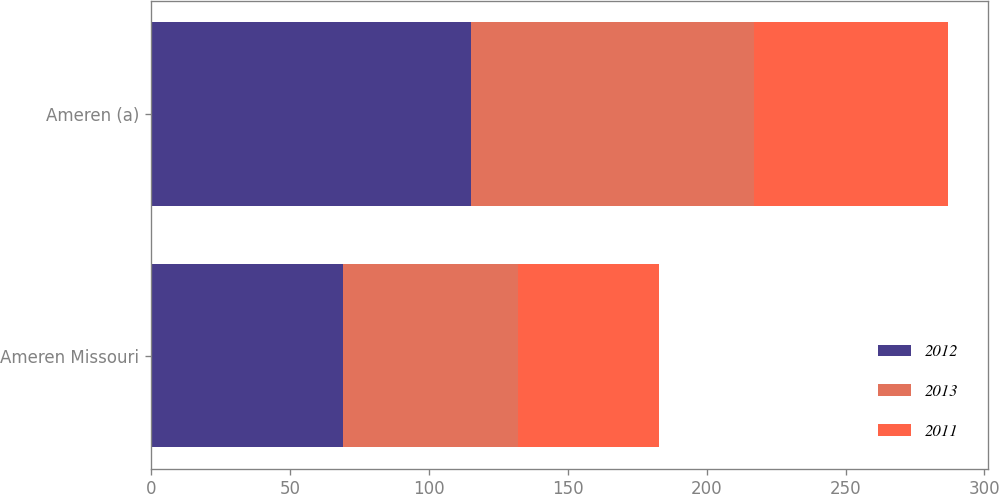Convert chart to OTSL. <chart><loc_0><loc_0><loc_500><loc_500><stacked_bar_chart><ecel><fcel>Ameren Missouri<fcel>Ameren (a)<nl><fcel>2012<fcel>69<fcel>115<nl><fcel>2013<fcel>63<fcel>102<nl><fcel>2011<fcel>51<fcel>70<nl></chart> 